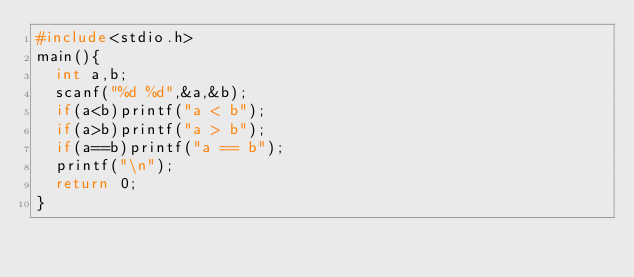Convert code to text. <code><loc_0><loc_0><loc_500><loc_500><_C_>#include<stdio.h>
main(){
  int a,b;
  scanf("%d %d",&a,&b);
  if(a<b)printf("a < b");
  if(a>b)printf("a > b");
  if(a==b)printf("a == b");
  printf("\n");
  return 0;
}
</code> 